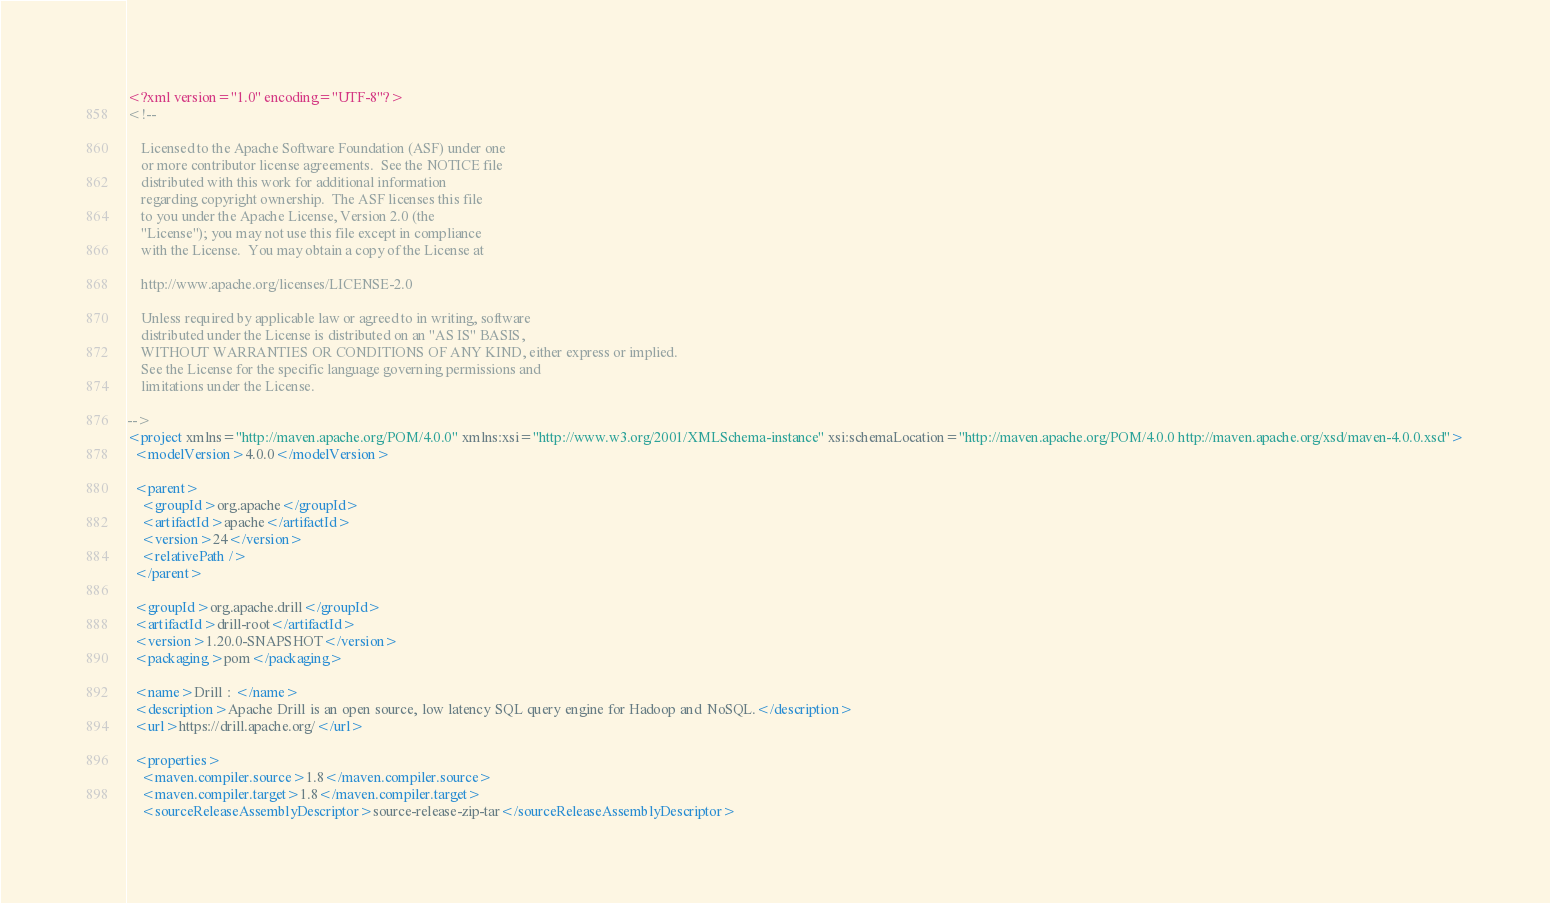<code> <loc_0><loc_0><loc_500><loc_500><_XML_><?xml version="1.0" encoding="UTF-8"?>
<!--

    Licensed to the Apache Software Foundation (ASF) under one
    or more contributor license agreements.  See the NOTICE file
    distributed with this work for additional information
    regarding copyright ownership.  The ASF licenses this file
    to you under the Apache License, Version 2.0 (the
    "License"); you may not use this file except in compliance
    with the License.  You may obtain a copy of the License at

    http://www.apache.org/licenses/LICENSE-2.0

    Unless required by applicable law or agreed to in writing, software
    distributed under the License is distributed on an "AS IS" BASIS,
    WITHOUT WARRANTIES OR CONDITIONS OF ANY KIND, either express or implied.
    See the License for the specific language governing permissions and
    limitations under the License.

-->
<project xmlns="http://maven.apache.org/POM/4.0.0" xmlns:xsi="http://www.w3.org/2001/XMLSchema-instance" xsi:schemaLocation="http://maven.apache.org/POM/4.0.0 http://maven.apache.org/xsd/maven-4.0.0.xsd">
  <modelVersion>4.0.0</modelVersion>

  <parent>
    <groupId>org.apache</groupId>
    <artifactId>apache</artifactId>
    <version>24</version>
    <relativePath />
  </parent>

  <groupId>org.apache.drill</groupId>
  <artifactId>drill-root</artifactId>
  <version>1.20.0-SNAPSHOT</version>
  <packaging>pom</packaging>

  <name>Drill : </name>
  <description>Apache Drill is an open source, low latency SQL query engine for Hadoop and NoSQL.</description>
  <url>https://drill.apache.org/</url>

  <properties>
    <maven.compiler.source>1.8</maven.compiler.source>
    <maven.compiler.target>1.8</maven.compiler.target>
    <sourceReleaseAssemblyDescriptor>source-release-zip-tar</sourceReleaseAssemblyDescriptor></code> 